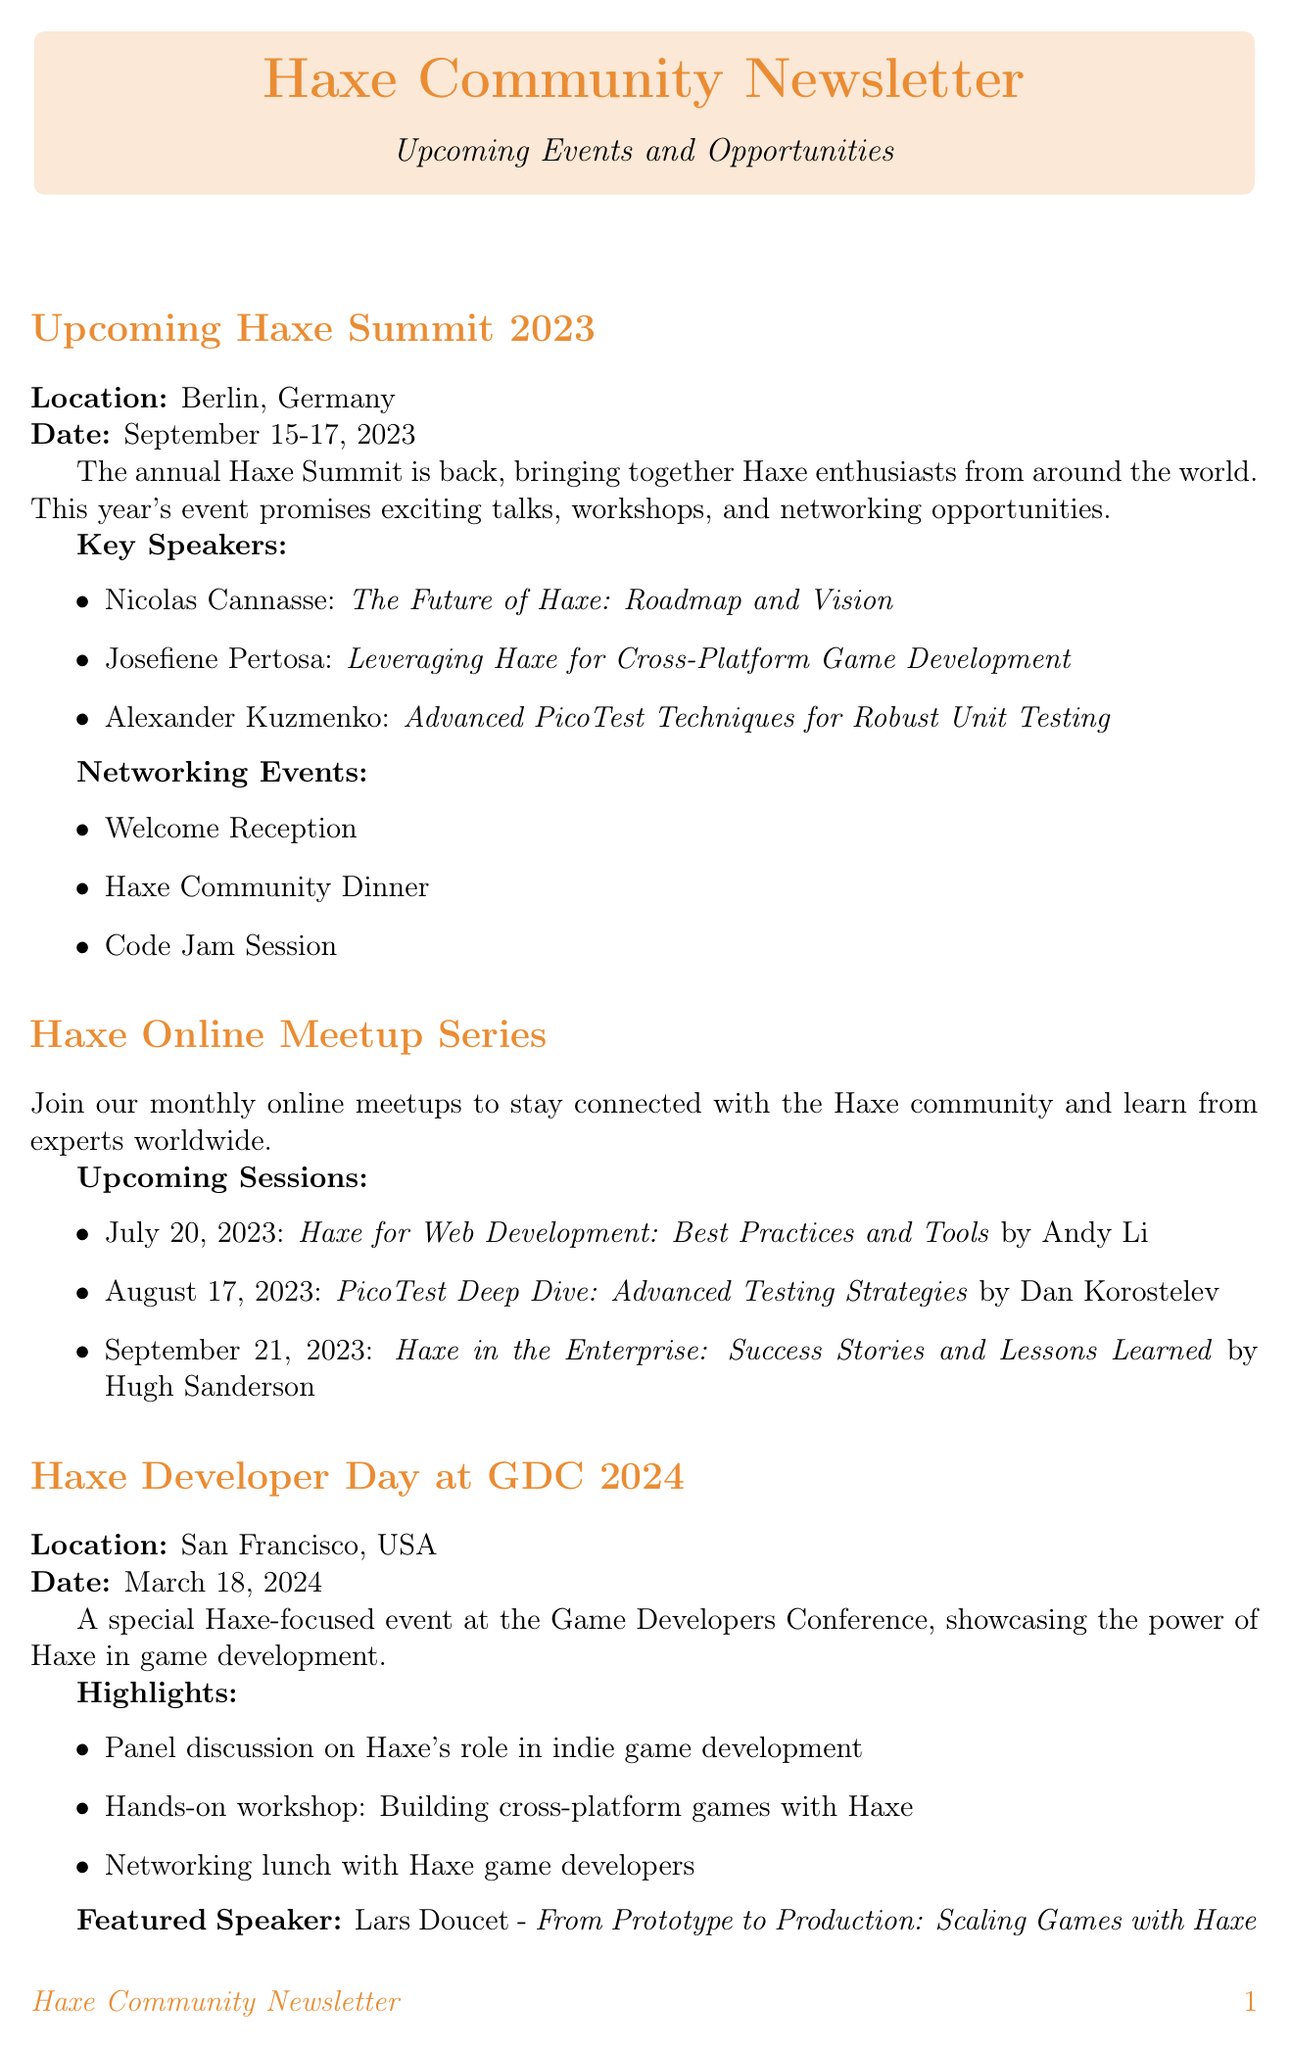What is the location of the Haxe Summit 2023? The location is specified in the document under the Haxe Summit 2023 section.
Answer: Berlin, Germany Who is the featured speaker at the Haxe Developer Day at GDC 2024? This information is listed in the highlights section of the Haxe Developer Day at GDC 2024.
Answer: Lars Doucet What date is the European Haxe Conference 2024 scheduled for? The date is mentioned in the document under the European Haxe Conference 2024 section.
Answer: June 5-7, 2024 What networking event will occur at the Haxe Summit 2023? The networking events are listed in the Haxe Summit 2023 section.
Answer: Welcome Reception How many upcoming sessions are listed in the Haxe Online Meetup Series? The number of sessions can be counted from the upcoming sessions list provided in that section.
Answer: 3 What is the topic of the talk by Josefiene Pertosa at the Haxe Summit 2023? This is found in the key speakers section of the Haxe Summit 2023.
Answer: Leveraging Haxe for Cross-Platform Game Development When is the deadline for the call for speakers for the European Haxe Conference 2024? The deadline for speaker submissions is provided in the call for speakers section.
Answer: February 15, 2024 What type of event will the Haxe Contributor Workshop be? This event is categorized under special events for the European Haxe Conference 2024.
Answer: Workshop 